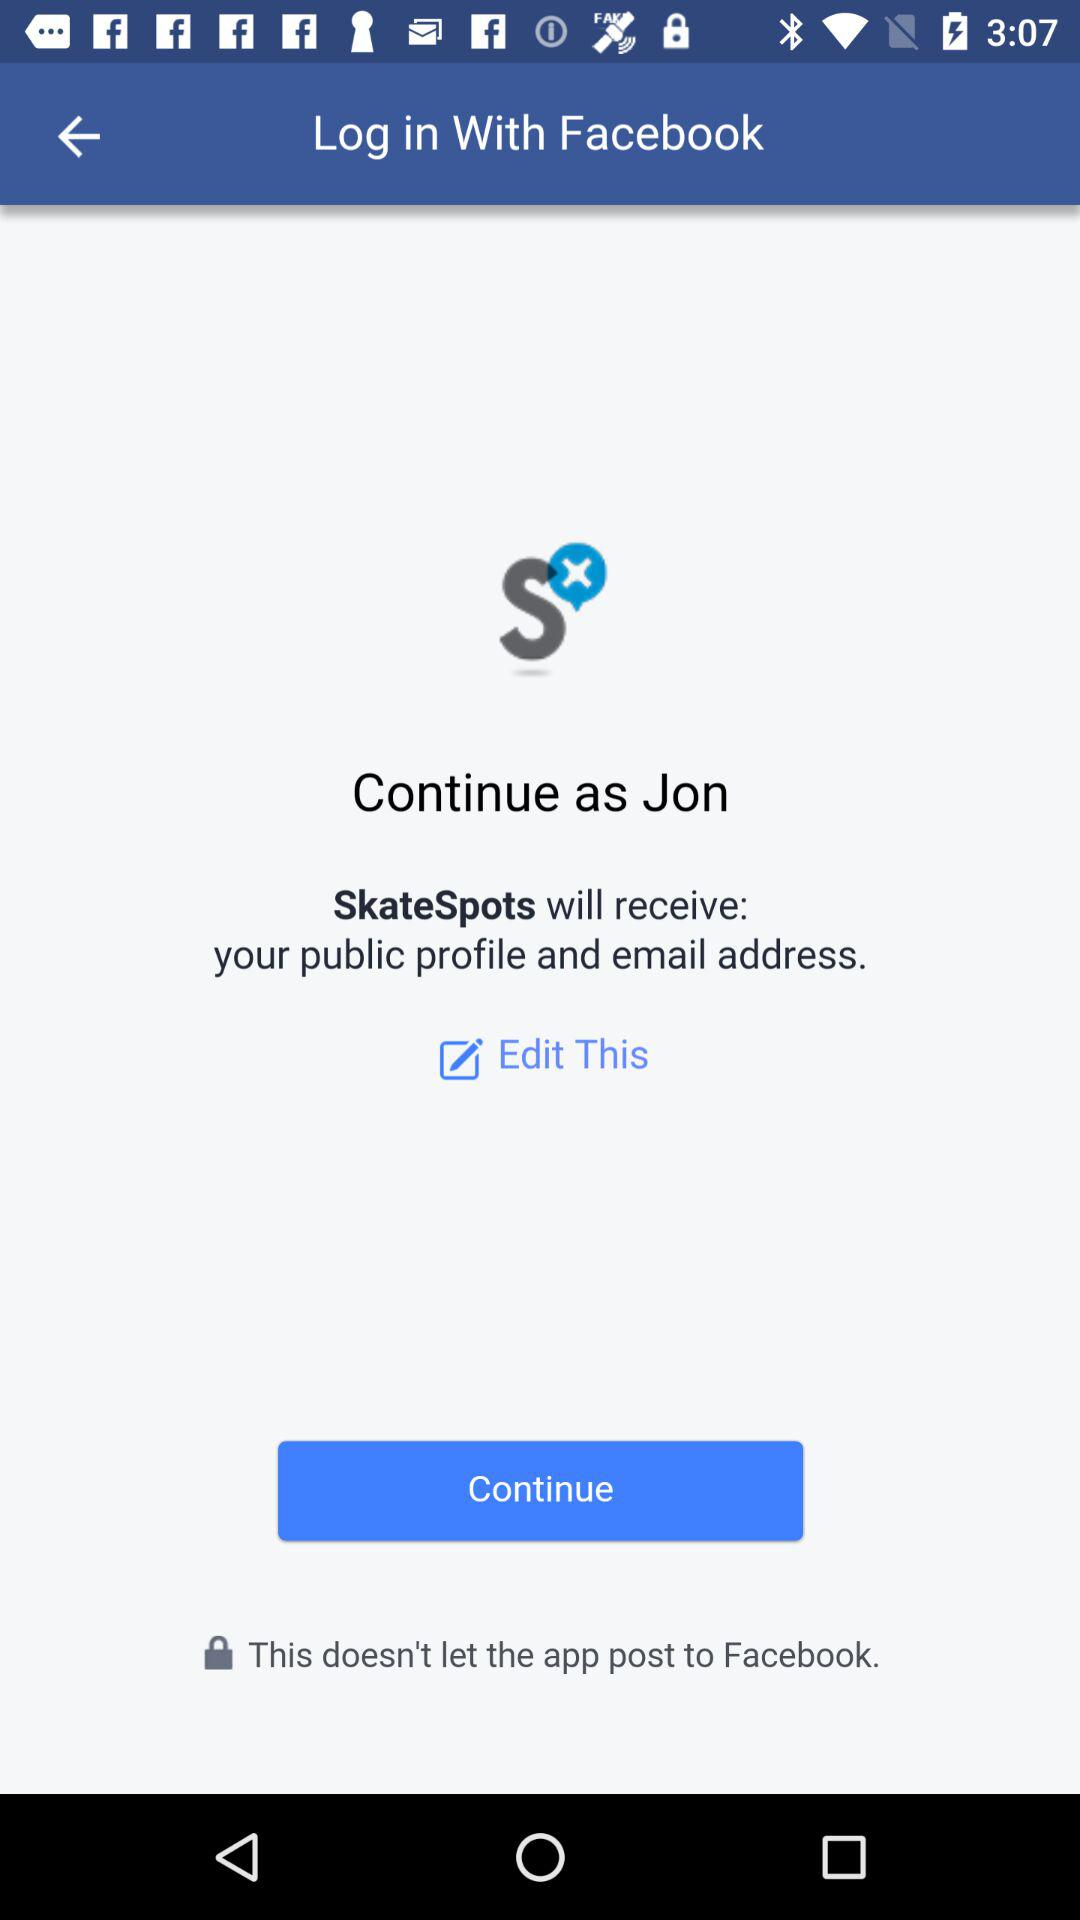How can we log in? You can log in with "Facebook". 